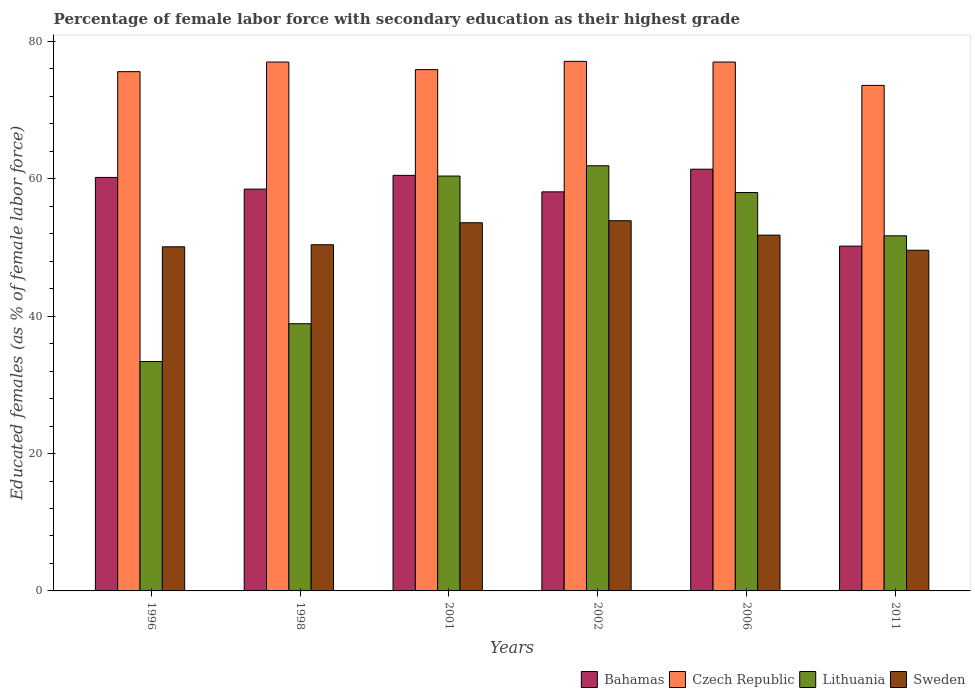How many different coloured bars are there?
Give a very brief answer. 4. How many groups of bars are there?
Keep it short and to the point. 6. Are the number of bars per tick equal to the number of legend labels?
Offer a very short reply. Yes. How many bars are there on the 3rd tick from the right?
Your response must be concise. 4. What is the percentage of female labor force with secondary education in Sweden in 1996?
Give a very brief answer. 50.1. Across all years, what is the maximum percentage of female labor force with secondary education in Sweden?
Offer a very short reply. 53.9. Across all years, what is the minimum percentage of female labor force with secondary education in Lithuania?
Keep it short and to the point. 33.4. In which year was the percentage of female labor force with secondary education in Lithuania maximum?
Keep it short and to the point. 2002. What is the total percentage of female labor force with secondary education in Bahamas in the graph?
Ensure brevity in your answer.  348.9. What is the difference between the percentage of female labor force with secondary education in Lithuania in 1998 and that in 2001?
Offer a very short reply. -21.5. What is the difference between the percentage of female labor force with secondary education in Lithuania in 2001 and the percentage of female labor force with secondary education in Sweden in 1996?
Ensure brevity in your answer.  10.3. What is the average percentage of female labor force with secondary education in Czech Republic per year?
Your answer should be compact. 76.03. In the year 2011, what is the difference between the percentage of female labor force with secondary education in Sweden and percentage of female labor force with secondary education in Bahamas?
Keep it short and to the point. -0.6. What is the ratio of the percentage of female labor force with secondary education in Sweden in 1996 to that in 2001?
Your response must be concise. 0.93. Is the percentage of female labor force with secondary education in Czech Republic in 2001 less than that in 2006?
Keep it short and to the point. Yes. What is the difference between the highest and the second highest percentage of female labor force with secondary education in Czech Republic?
Make the answer very short. 0.1. What is the difference between the highest and the lowest percentage of female labor force with secondary education in Czech Republic?
Your answer should be compact. 3.5. In how many years, is the percentage of female labor force with secondary education in Sweden greater than the average percentage of female labor force with secondary education in Sweden taken over all years?
Offer a terse response. 3. Is it the case that in every year, the sum of the percentage of female labor force with secondary education in Lithuania and percentage of female labor force with secondary education in Czech Republic is greater than the sum of percentage of female labor force with secondary education in Bahamas and percentage of female labor force with secondary education in Sweden?
Your answer should be compact. No. What does the 2nd bar from the left in 2011 represents?
Your answer should be compact. Czech Republic. What does the 2nd bar from the right in 2001 represents?
Provide a succinct answer. Lithuania. Is it the case that in every year, the sum of the percentage of female labor force with secondary education in Bahamas and percentage of female labor force with secondary education in Lithuania is greater than the percentage of female labor force with secondary education in Czech Republic?
Provide a succinct answer. Yes. What is the difference between two consecutive major ticks on the Y-axis?
Make the answer very short. 20. Where does the legend appear in the graph?
Your answer should be very brief. Bottom right. How many legend labels are there?
Make the answer very short. 4. What is the title of the graph?
Ensure brevity in your answer.  Percentage of female labor force with secondary education as their highest grade. Does "Europe(developing only)" appear as one of the legend labels in the graph?
Your response must be concise. No. What is the label or title of the X-axis?
Your response must be concise. Years. What is the label or title of the Y-axis?
Your answer should be very brief. Educated females (as % of female labor force). What is the Educated females (as % of female labor force) of Bahamas in 1996?
Your answer should be very brief. 60.2. What is the Educated females (as % of female labor force) in Czech Republic in 1996?
Offer a very short reply. 75.6. What is the Educated females (as % of female labor force) of Lithuania in 1996?
Your answer should be compact. 33.4. What is the Educated females (as % of female labor force) of Sweden in 1996?
Provide a short and direct response. 50.1. What is the Educated females (as % of female labor force) of Bahamas in 1998?
Ensure brevity in your answer.  58.5. What is the Educated females (as % of female labor force) of Czech Republic in 1998?
Offer a very short reply. 77. What is the Educated females (as % of female labor force) of Lithuania in 1998?
Give a very brief answer. 38.9. What is the Educated females (as % of female labor force) in Sweden in 1998?
Ensure brevity in your answer.  50.4. What is the Educated females (as % of female labor force) of Bahamas in 2001?
Provide a short and direct response. 60.5. What is the Educated females (as % of female labor force) of Czech Republic in 2001?
Give a very brief answer. 75.9. What is the Educated females (as % of female labor force) of Lithuania in 2001?
Keep it short and to the point. 60.4. What is the Educated females (as % of female labor force) of Sweden in 2001?
Offer a terse response. 53.6. What is the Educated females (as % of female labor force) of Bahamas in 2002?
Your answer should be compact. 58.1. What is the Educated females (as % of female labor force) in Czech Republic in 2002?
Keep it short and to the point. 77.1. What is the Educated females (as % of female labor force) of Lithuania in 2002?
Provide a short and direct response. 61.9. What is the Educated females (as % of female labor force) in Sweden in 2002?
Your answer should be very brief. 53.9. What is the Educated females (as % of female labor force) in Bahamas in 2006?
Your answer should be compact. 61.4. What is the Educated females (as % of female labor force) in Sweden in 2006?
Your answer should be very brief. 51.8. What is the Educated females (as % of female labor force) in Bahamas in 2011?
Provide a short and direct response. 50.2. What is the Educated females (as % of female labor force) in Czech Republic in 2011?
Provide a short and direct response. 73.6. What is the Educated females (as % of female labor force) in Lithuania in 2011?
Your answer should be compact. 51.7. What is the Educated females (as % of female labor force) of Sweden in 2011?
Offer a very short reply. 49.6. Across all years, what is the maximum Educated females (as % of female labor force) in Bahamas?
Provide a succinct answer. 61.4. Across all years, what is the maximum Educated females (as % of female labor force) of Czech Republic?
Ensure brevity in your answer.  77.1. Across all years, what is the maximum Educated females (as % of female labor force) in Lithuania?
Keep it short and to the point. 61.9. Across all years, what is the maximum Educated females (as % of female labor force) of Sweden?
Provide a short and direct response. 53.9. Across all years, what is the minimum Educated females (as % of female labor force) of Bahamas?
Offer a very short reply. 50.2. Across all years, what is the minimum Educated females (as % of female labor force) in Czech Republic?
Your answer should be compact. 73.6. Across all years, what is the minimum Educated females (as % of female labor force) of Lithuania?
Make the answer very short. 33.4. Across all years, what is the minimum Educated females (as % of female labor force) of Sweden?
Provide a succinct answer. 49.6. What is the total Educated females (as % of female labor force) in Bahamas in the graph?
Offer a terse response. 348.9. What is the total Educated females (as % of female labor force) of Czech Republic in the graph?
Offer a terse response. 456.2. What is the total Educated females (as % of female labor force) in Lithuania in the graph?
Your response must be concise. 304.3. What is the total Educated females (as % of female labor force) of Sweden in the graph?
Keep it short and to the point. 309.4. What is the difference between the Educated females (as % of female labor force) in Bahamas in 1996 and that in 1998?
Offer a very short reply. 1.7. What is the difference between the Educated females (as % of female labor force) in Sweden in 1996 and that in 1998?
Make the answer very short. -0.3. What is the difference between the Educated females (as % of female labor force) in Bahamas in 1996 and that in 2001?
Your answer should be compact. -0.3. What is the difference between the Educated females (as % of female labor force) of Czech Republic in 1996 and that in 2001?
Your answer should be compact. -0.3. What is the difference between the Educated females (as % of female labor force) in Sweden in 1996 and that in 2001?
Your response must be concise. -3.5. What is the difference between the Educated females (as % of female labor force) in Bahamas in 1996 and that in 2002?
Your response must be concise. 2.1. What is the difference between the Educated females (as % of female labor force) of Czech Republic in 1996 and that in 2002?
Your answer should be very brief. -1.5. What is the difference between the Educated females (as % of female labor force) of Lithuania in 1996 and that in 2002?
Keep it short and to the point. -28.5. What is the difference between the Educated females (as % of female labor force) in Bahamas in 1996 and that in 2006?
Your answer should be compact. -1.2. What is the difference between the Educated females (as % of female labor force) in Czech Republic in 1996 and that in 2006?
Keep it short and to the point. -1.4. What is the difference between the Educated females (as % of female labor force) of Lithuania in 1996 and that in 2006?
Give a very brief answer. -24.6. What is the difference between the Educated females (as % of female labor force) of Sweden in 1996 and that in 2006?
Provide a short and direct response. -1.7. What is the difference between the Educated females (as % of female labor force) in Czech Republic in 1996 and that in 2011?
Offer a terse response. 2. What is the difference between the Educated females (as % of female labor force) of Lithuania in 1996 and that in 2011?
Provide a short and direct response. -18.3. What is the difference between the Educated females (as % of female labor force) in Lithuania in 1998 and that in 2001?
Provide a short and direct response. -21.5. What is the difference between the Educated females (as % of female labor force) in Bahamas in 1998 and that in 2002?
Give a very brief answer. 0.4. What is the difference between the Educated females (as % of female labor force) in Bahamas in 1998 and that in 2006?
Your answer should be compact. -2.9. What is the difference between the Educated females (as % of female labor force) of Lithuania in 1998 and that in 2006?
Keep it short and to the point. -19.1. What is the difference between the Educated females (as % of female labor force) of Sweden in 1998 and that in 2006?
Your response must be concise. -1.4. What is the difference between the Educated females (as % of female labor force) in Bahamas in 1998 and that in 2011?
Your answer should be very brief. 8.3. What is the difference between the Educated females (as % of female labor force) of Czech Republic in 1998 and that in 2011?
Keep it short and to the point. 3.4. What is the difference between the Educated females (as % of female labor force) in Sweden in 1998 and that in 2011?
Offer a terse response. 0.8. What is the difference between the Educated females (as % of female labor force) in Bahamas in 2001 and that in 2002?
Ensure brevity in your answer.  2.4. What is the difference between the Educated females (as % of female labor force) of Sweden in 2001 and that in 2002?
Your answer should be compact. -0.3. What is the difference between the Educated females (as % of female labor force) of Lithuania in 2001 and that in 2006?
Your answer should be very brief. 2.4. What is the difference between the Educated females (as % of female labor force) in Sweden in 2001 and that in 2006?
Offer a very short reply. 1.8. What is the difference between the Educated females (as % of female labor force) of Bahamas in 2001 and that in 2011?
Give a very brief answer. 10.3. What is the difference between the Educated females (as % of female labor force) of Sweden in 2001 and that in 2011?
Keep it short and to the point. 4. What is the difference between the Educated females (as % of female labor force) in Czech Republic in 2002 and that in 2006?
Keep it short and to the point. 0.1. What is the difference between the Educated females (as % of female labor force) of Sweden in 2002 and that in 2006?
Ensure brevity in your answer.  2.1. What is the difference between the Educated females (as % of female labor force) of Sweden in 2002 and that in 2011?
Offer a very short reply. 4.3. What is the difference between the Educated females (as % of female labor force) in Bahamas in 2006 and that in 2011?
Keep it short and to the point. 11.2. What is the difference between the Educated females (as % of female labor force) of Lithuania in 2006 and that in 2011?
Keep it short and to the point. 6.3. What is the difference between the Educated females (as % of female labor force) in Sweden in 2006 and that in 2011?
Offer a very short reply. 2.2. What is the difference between the Educated females (as % of female labor force) in Bahamas in 1996 and the Educated females (as % of female labor force) in Czech Republic in 1998?
Your answer should be compact. -16.8. What is the difference between the Educated females (as % of female labor force) of Bahamas in 1996 and the Educated females (as % of female labor force) of Lithuania in 1998?
Your answer should be compact. 21.3. What is the difference between the Educated females (as % of female labor force) in Czech Republic in 1996 and the Educated females (as % of female labor force) in Lithuania in 1998?
Your answer should be compact. 36.7. What is the difference between the Educated females (as % of female labor force) in Czech Republic in 1996 and the Educated females (as % of female labor force) in Sweden in 1998?
Offer a terse response. 25.2. What is the difference between the Educated females (as % of female labor force) of Bahamas in 1996 and the Educated females (as % of female labor force) of Czech Republic in 2001?
Your answer should be very brief. -15.7. What is the difference between the Educated females (as % of female labor force) in Czech Republic in 1996 and the Educated females (as % of female labor force) in Lithuania in 2001?
Offer a terse response. 15.2. What is the difference between the Educated females (as % of female labor force) in Czech Republic in 1996 and the Educated females (as % of female labor force) in Sweden in 2001?
Give a very brief answer. 22. What is the difference between the Educated females (as % of female labor force) in Lithuania in 1996 and the Educated females (as % of female labor force) in Sweden in 2001?
Ensure brevity in your answer.  -20.2. What is the difference between the Educated females (as % of female labor force) of Bahamas in 1996 and the Educated females (as % of female labor force) of Czech Republic in 2002?
Make the answer very short. -16.9. What is the difference between the Educated females (as % of female labor force) of Bahamas in 1996 and the Educated females (as % of female labor force) of Lithuania in 2002?
Offer a very short reply. -1.7. What is the difference between the Educated females (as % of female labor force) of Czech Republic in 1996 and the Educated females (as % of female labor force) of Sweden in 2002?
Your answer should be very brief. 21.7. What is the difference between the Educated females (as % of female labor force) of Lithuania in 1996 and the Educated females (as % of female labor force) of Sweden in 2002?
Keep it short and to the point. -20.5. What is the difference between the Educated females (as % of female labor force) of Bahamas in 1996 and the Educated females (as % of female labor force) of Czech Republic in 2006?
Keep it short and to the point. -16.8. What is the difference between the Educated females (as % of female labor force) of Bahamas in 1996 and the Educated females (as % of female labor force) of Sweden in 2006?
Give a very brief answer. 8.4. What is the difference between the Educated females (as % of female labor force) in Czech Republic in 1996 and the Educated females (as % of female labor force) in Lithuania in 2006?
Provide a short and direct response. 17.6. What is the difference between the Educated females (as % of female labor force) in Czech Republic in 1996 and the Educated females (as % of female labor force) in Sweden in 2006?
Keep it short and to the point. 23.8. What is the difference between the Educated females (as % of female labor force) of Lithuania in 1996 and the Educated females (as % of female labor force) of Sweden in 2006?
Your response must be concise. -18.4. What is the difference between the Educated females (as % of female labor force) in Bahamas in 1996 and the Educated females (as % of female labor force) in Sweden in 2011?
Your response must be concise. 10.6. What is the difference between the Educated females (as % of female labor force) of Czech Republic in 1996 and the Educated females (as % of female labor force) of Lithuania in 2011?
Your answer should be compact. 23.9. What is the difference between the Educated females (as % of female labor force) in Lithuania in 1996 and the Educated females (as % of female labor force) in Sweden in 2011?
Ensure brevity in your answer.  -16.2. What is the difference between the Educated females (as % of female labor force) in Bahamas in 1998 and the Educated females (as % of female labor force) in Czech Republic in 2001?
Give a very brief answer. -17.4. What is the difference between the Educated females (as % of female labor force) of Bahamas in 1998 and the Educated females (as % of female labor force) of Sweden in 2001?
Keep it short and to the point. 4.9. What is the difference between the Educated females (as % of female labor force) of Czech Republic in 1998 and the Educated females (as % of female labor force) of Sweden in 2001?
Offer a very short reply. 23.4. What is the difference between the Educated females (as % of female labor force) of Lithuania in 1998 and the Educated females (as % of female labor force) of Sweden in 2001?
Give a very brief answer. -14.7. What is the difference between the Educated females (as % of female labor force) in Bahamas in 1998 and the Educated females (as % of female labor force) in Czech Republic in 2002?
Ensure brevity in your answer.  -18.6. What is the difference between the Educated females (as % of female labor force) in Bahamas in 1998 and the Educated females (as % of female labor force) in Lithuania in 2002?
Offer a terse response. -3.4. What is the difference between the Educated females (as % of female labor force) of Bahamas in 1998 and the Educated females (as % of female labor force) of Sweden in 2002?
Your answer should be compact. 4.6. What is the difference between the Educated females (as % of female labor force) in Czech Republic in 1998 and the Educated females (as % of female labor force) in Lithuania in 2002?
Your answer should be compact. 15.1. What is the difference between the Educated females (as % of female labor force) in Czech Republic in 1998 and the Educated females (as % of female labor force) in Sweden in 2002?
Give a very brief answer. 23.1. What is the difference between the Educated females (as % of female labor force) of Bahamas in 1998 and the Educated females (as % of female labor force) of Czech Republic in 2006?
Keep it short and to the point. -18.5. What is the difference between the Educated females (as % of female labor force) of Bahamas in 1998 and the Educated females (as % of female labor force) of Sweden in 2006?
Provide a short and direct response. 6.7. What is the difference between the Educated females (as % of female labor force) of Czech Republic in 1998 and the Educated females (as % of female labor force) of Lithuania in 2006?
Keep it short and to the point. 19. What is the difference between the Educated females (as % of female labor force) of Czech Republic in 1998 and the Educated females (as % of female labor force) of Sweden in 2006?
Offer a terse response. 25.2. What is the difference between the Educated females (as % of female labor force) in Lithuania in 1998 and the Educated females (as % of female labor force) in Sweden in 2006?
Offer a terse response. -12.9. What is the difference between the Educated females (as % of female labor force) of Bahamas in 1998 and the Educated females (as % of female labor force) of Czech Republic in 2011?
Your answer should be very brief. -15.1. What is the difference between the Educated females (as % of female labor force) of Bahamas in 1998 and the Educated females (as % of female labor force) of Lithuania in 2011?
Keep it short and to the point. 6.8. What is the difference between the Educated females (as % of female labor force) of Czech Republic in 1998 and the Educated females (as % of female labor force) of Lithuania in 2011?
Keep it short and to the point. 25.3. What is the difference between the Educated females (as % of female labor force) of Czech Republic in 1998 and the Educated females (as % of female labor force) of Sweden in 2011?
Offer a very short reply. 27.4. What is the difference between the Educated females (as % of female labor force) of Bahamas in 2001 and the Educated females (as % of female labor force) of Czech Republic in 2002?
Provide a succinct answer. -16.6. What is the difference between the Educated females (as % of female labor force) of Czech Republic in 2001 and the Educated females (as % of female labor force) of Lithuania in 2002?
Your answer should be compact. 14. What is the difference between the Educated females (as % of female labor force) of Bahamas in 2001 and the Educated females (as % of female labor force) of Czech Republic in 2006?
Your response must be concise. -16.5. What is the difference between the Educated females (as % of female labor force) of Bahamas in 2001 and the Educated females (as % of female labor force) of Lithuania in 2006?
Ensure brevity in your answer.  2.5. What is the difference between the Educated females (as % of female labor force) in Bahamas in 2001 and the Educated females (as % of female labor force) in Sweden in 2006?
Offer a very short reply. 8.7. What is the difference between the Educated females (as % of female labor force) in Czech Republic in 2001 and the Educated females (as % of female labor force) in Sweden in 2006?
Make the answer very short. 24.1. What is the difference between the Educated females (as % of female labor force) of Bahamas in 2001 and the Educated females (as % of female labor force) of Lithuania in 2011?
Make the answer very short. 8.8. What is the difference between the Educated females (as % of female labor force) in Bahamas in 2001 and the Educated females (as % of female labor force) in Sweden in 2011?
Give a very brief answer. 10.9. What is the difference between the Educated females (as % of female labor force) of Czech Republic in 2001 and the Educated females (as % of female labor force) of Lithuania in 2011?
Offer a very short reply. 24.2. What is the difference between the Educated females (as % of female labor force) in Czech Republic in 2001 and the Educated females (as % of female labor force) in Sweden in 2011?
Make the answer very short. 26.3. What is the difference between the Educated females (as % of female labor force) in Bahamas in 2002 and the Educated females (as % of female labor force) in Czech Republic in 2006?
Your answer should be very brief. -18.9. What is the difference between the Educated females (as % of female labor force) of Czech Republic in 2002 and the Educated females (as % of female labor force) of Sweden in 2006?
Provide a short and direct response. 25.3. What is the difference between the Educated females (as % of female labor force) in Lithuania in 2002 and the Educated females (as % of female labor force) in Sweden in 2006?
Provide a succinct answer. 10.1. What is the difference between the Educated females (as % of female labor force) in Bahamas in 2002 and the Educated females (as % of female labor force) in Czech Republic in 2011?
Make the answer very short. -15.5. What is the difference between the Educated females (as % of female labor force) in Bahamas in 2002 and the Educated females (as % of female labor force) in Lithuania in 2011?
Give a very brief answer. 6.4. What is the difference between the Educated females (as % of female labor force) in Bahamas in 2002 and the Educated females (as % of female labor force) in Sweden in 2011?
Your answer should be very brief. 8.5. What is the difference between the Educated females (as % of female labor force) of Czech Republic in 2002 and the Educated females (as % of female labor force) of Lithuania in 2011?
Offer a very short reply. 25.4. What is the difference between the Educated females (as % of female labor force) of Czech Republic in 2002 and the Educated females (as % of female labor force) of Sweden in 2011?
Offer a very short reply. 27.5. What is the difference between the Educated females (as % of female labor force) in Lithuania in 2002 and the Educated females (as % of female labor force) in Sweden in 2011?
Your response must be concise. 12.3. What is the difference between the Educated females (as % of female labor force) of Bahamas in 2006 and the Educated females (as % of female labor force) of Sweden in 2011?
Give a very brief answer. 11.8. What is the difference between the Educated females (as % of female labor force) in Czech Republic in 2006 and the Educated females (as % of female labor force) in Lithuania in 2011?
Keep it short and to the point. 25.3. What is the difference between the Educated females (as % of female labor force) of Czech Republic in 2006 and the Educated females (as % of female labor force) of Sweden in 2011?
Provide a short and direct response. 27.4. What is the difference between the Educated females (as % of female labor force) in Lithuania in 2006 and the Educated females (as % of female labor force) in Sweden in 2011?
Provide a short and direct response. 8.4. What is the average Educated females (as % of female labor force) in Bahamas per year?
Offer a very short reply. 58.15. What is the average Educated females (as % of female labor force) in Czech Republic per year?
Provide a short and direct response. 76.03. What is the average Educated females (as % of female labor force) in Lithuania per year?
Provide a succinct answer. 50.72. What is the average Educated females (as % of female labor force) of Sweden per year?
Offer a terse response. 51.57. In the year 1996, what is the difference between the Educated females (as % of female labor force) in Bahamas and Educated females (as % of female labor force) in Czech Republic?
Your answer should be compact. -15.4. In the year 1996, what is the difference between the Educated females (as % of female labor force) in Bahamas and Educated females (as % of female labor force) in Lithuania?
Give a very brief answer. 26.8. In the year 1996, what is the difference between the Educated females (as % of female labor force) of Bahamas and Educated females (as % of female labor force) of Sweden?
Provide a short and direct response. 10.1. In the year 1996, what is the difference between the Educated females (as % of female labor force) of Czech Republic and Educated females (as % of female labor force) of Lithuania?
Offer a terse response. 42.2. In the year 1996, what is the difference between the Educated females (as % of female labor force) of Lithuania and Educated females (as % of female labor force) of Sweden?
Your response must be concise. -16.7. In the year 1998, what is the difference between the Educated females (as % of female labor force) of Bahamas and Educated females (as % of female labor force) of Czech Republic?
Ensure brevity in your answer.  -18.5. In the year 1998, what is the difference between the Educated females (as % of female labor force) in Bahamas and Educated females (as % of female labor force) in Lithuania?
Ensure brevity in your answer.  19.6. In the year 1998, what is the difference between the Educated females (as % of female labor force) of Bahamas and Educated females (as % of female labor force) of Sweden?
Your answer should be compact. 8.1. In the year 1998, what is the difference between the Educated females (as % of female labor force) in Czech Republic and Educated females (as % of female labor force) in Lithuania?
Keep it short and to the point. 38.1. In the year 1998, what is the difference between the Educated females (as % of female labor force) in Czech Republic and Educated females (as % of female labor force) in Sweden?
Make the answer very short. 26.6. In the year 2001, what is the difference between the Educated females (as % of female labor force) in Bahamas and Educated females (as % of female labor force) in Czech Republic?
Make the answer very short. -15.4. In the year 2001, what is the difference between the Educated females (as % of female labor force) in Bahamas and Educated females (as % of female labor force) in Lithuania?
Your answer should be compact. 0.1. In the year 2001, what is the difference between the Educated females (as % of female labor force) of Czech Republic and Educated females (as % of female labor force) of Sweden?
Offer a terse response. 22.3. In the year 2001, what is the difference between the Educated females (as % of female labor force) of Lithuania and Educated females (as % of female labor force) of Sweden?
Offer a very short reply. 6.8. In the year 2002, what is the difference between the Educated females (as % of female labor force) in Bahamas and Educated females (as % of female labor force) in Sweden?
Your response must be concise. 4.2. In the year 2002, what is the difference between the Educated females (as % of female labor force) of Czech Republic and Educated females (as % of female labor force) of Sweden?
Keep it short and to the point. 23.2. In the year 2006, what is the difference between the Educated females (as % of female labor force) in Bahamas and Educated females (as % of female labor force) in Czech Republic?
Give a very brief answer. -15.6. In the year 2006, what is the difference between the Educated females (as % of female labor force) of Czech Republic and Educated females (as % of female labor force) of Lithuania?
Your answer should be very brief. 19. In the year 2006, what is the difference between the Educated females (as % of female labor force) of Czech Republic and Educated females (as % of female labor force) of Sweden?
Give a very brief answer. 25.2. In the year 2011, what is the difference between the Educated females (as % of female labor force) in Bahamas and Educated females (as % of female labor force) in Czech Republic?
Give a very brief answer. -23.4. In the year 2011, what is the difference between the Educated females (as % of female labor force) in Bahamas and Educated females (as % of female labor force) in Lithuania?
Offer a terse response. -1.5. In the year 2011, what is the difference between the Educated females (as % of female labor force) in Czech Republic and Educated females (as % of female labor force) in Lithuania?
Make the answer very short. 21.9. In the year 2011, what is the difference between the Educated females (as % of female labor force) in Czech Republic and Educated females (as % of female labor force) in Sweden?
Keep it short and to the point. 24. In the year 2011, what is the difference between the Educated females (as % of female labor force) of Lithuania and Educated females (as % of female labor force) of Sweden?
Your answer should be compact. 2.1. What is the ratio of the Educated females (as % of female labor force) in Bahamas in 1996 to that in 1998?
Ensure brevity in your answer.  1.03. What is the ratio of the Educated females (as % of female labor force) of Czech Republic in 1996 to that in 1998?
Offer a terse response. 0.98. What is the ratio of the Educated females (as % of female labor force) in Lithuania in 1996 to that in 1998?
Offer a terse response. 0.86. What is the ratio of the Educated females (as % of female labor force) of Sweden in 1996 to that in 1998?
Your answer should be compact. 0.99. What is the ratio of the Educated females (as % of female labor force) of Bahamas in 1996 to that in 2001?
Provide a short and direct response. 0.99. What is the ratio of the Educated females (as % of female labor force) in Czech Republic in 1996 to that in 2001?
Your response must be concise. 1. What is the ratio of the Educated females (as % of female labor force) of Lithuania in 1996 to that in 2001?
Make the answer very short. 0.55. What is the ratio of the Educated females (as % of female labor force) of Sweden in 1996 to that in 2001?
Provide a succinct answer. 0.93. What is the ratio of the Educated females (as % of female labor force) in Bahamas in 1996 to that in 2002?
Offer a very short reply. 1.04. What is the ratio of the Educated females (as % of female labor force) of Czech Republic in 1996 to that in 2002?
Your answer should be very brief. 0.98. What is the ratio of the Educated females (as % of female labor force) of Lithuania in 1996 to that in 2002?
Your response must be concise. 0.54. What is the ratio of the Educated females (as % of female labor force) in Sweden in 1996 to that in 2002?
Give a very brief answer. 0.93. What is the ratio of the Educated females (as % of female labor force) in Bahamas in 1996 to that in 2006?
Provide a short and direct response. 0.98. What is the ratio of the Educated females (as % of female labor force) of Czech Republic in 1996 to that in 2006?
Offer a very short reply. 0.98. What is the ratio of the Educated females (as % of female labor force) in Lithuania in 1996 to that in 2006?
Your response must be concise. 0.58. What is the ratio of the Educated females (as % of female labor force) in Sweden in 1996 to that in 2006?
Offer a very short reply. 0.97. What is the ratio of the Educated females (as % of female labor force) of Bahamas in 1996 to that in 2011?
Your answer should be very brief. 1.2. What is the ratio of the Educated females (as % of female labor force) in Czech Republic in 1996 to that in 2011?
Make the answer very short. 1.03. What is the ratio of the Educated females (as % of female labor force) in Lithuania in 1996 to that in 2011?
Your response must be concise. 0.65. What is the ratio of the Educated females (as % of female labor force) of Bahamas in 1998 to that in 2001?
Ensure brevity in your answer.  0.97. What is the ratio of the Educated females (as % of female labor force) of Czech Republic in 1998 to that in 2001?
Provide a short and direct response. 1.01. What is the ratio of the Educated females (as % of female labor force) of Lithuania in 1998 to that in 2001?
Provide a succinct answer. 0.64. What is the ratio of the Educated females (as % of female labor force) in Sweden in 1998 to that in 2001?
Make the answer very short. 0.94. What is the ratio of the Educated females (as % of female labor force) in Lithuania in 1998 to that in 2002?
Give a very brief answer. 0.63. What is the ratio of the Educated females (as % of female labor force) in Sweden in 1998 to that in 2002?
Provide a short and direct response. 0.94. What is the ratio of the Educated females (as % of female labor force) in Bahamas in 1998 to that in 2006?
Your response must be concise. 0.95. What is the ratio of the Educated females (as % of female labor force) in Czech Republic in 1998 to that in 2006?
Keep it short and to the point. 1. What is the ratio of the Educated females (as % of female labor force) in Lithuania in 1998 to that in 2006?
Provide a short and direct response. 0.67. What is the ratio of the Educated females (as % of female labor force) in Bahamas in 1998 to that in 2011?
Your answer should be compact. 1.17. What is the ratio of the Educated females (as % of female labor force) of Czech Republic in 1998 to that in 2011?
Provide a short and direct response. 1.05. What is the ratio of the Educated females (as % of female labor force) in Lithuania in 1998 to that in 2011?
Ensure brevity in your answer.  0.75. What is the ratio of the Educated females (as % of female labor force) of Sweden in 1998 to that in 2011?
Offer a terse response. 1.02. What is the ratio of the Educated females (as % of female labor force) of Bahamas in 2001 to that in 2002?
Offer a terse response. 1.04. What is the ratio of the Educated females (as % of female labor force) in Czech Republic in 2001 to that in 2002?
Offer a very short reply. 0.98. What is the ratio of the Educated females (as % of female labor force) in Lithuania in 2001 to that in 2002?
Keep it short and to the point. 0.98. What is the ratio of the Educated females (as % of female labor force) in Sweden in 2001 to that in 2002?
Your answer should be very brief. 0.99. What is the ratio of the Educated females (as % of female labor force) in Czech Republic in 2001 to that in 2006?
Your answer should be compact. 0.99. What is the ratio of the Educated females (as % of female labor force) in Lithuania in 2001 to that in 2006?
Your answer should be compact. 1.04. What is the ratio of the Educated females (as % of female labor force) of Sweden in 2001 to that in 2006?
Offer a very short reply. 1.03. What is the ratio of the Educated females (as % of female labor force) of Bahamas in 2001 to that in 2011?
Make the answer very short. 1.21. What is the ratio of the Educated females (as % of female labor force) of Czech Republic in 2001 to that in 2011?
Provide a succinct answer. 1.03. What is the ratio of the Educated females (as % of female labor force) in Lithuania in 2001 to that in 2011?
Keep it short and to the point. 1.17. What is the ratio of the Educated females (as % of female labor force) of Sweden in 2001 to that in 2011?
Your answer should be compact. 1.08. What is the ratio of the Educated females (as % of female labor force) of Bahamas in 2002 to that in 2006?
Make the answer very short. 0.95. What is the ratio of the Educated females (as % of female labor force) of Czech Republic in 2002 to that in 2006?
Provide a short and direct response. 1. What is the ratio of the Educated females (as % of female labor force) in Lithuania in 2002 to that in 2006?
Your answer should be very brief. 1.07. What is the ratio of the Educated females (as % of female labor force) of Sweden in 2002 to that in 2006?
Provide a short and direct response. 1.04. What is the ratio of the Educated females (as % of female labor force) of Bahamas in 2002 to that in 2011?
Your answer should be compact. 1.16. What is the ratio of the Educated females (as % of female labor force) of Czech Republic in 2002 to that in 2011?
Your answer should be compact. 1.05. What is the ratio of the Educated females (as % of female labor force) in Lithuania in 2002 to that in 2011?
Provide a succinct answer. 1.2. What is the ratio of the Educated females (as % of female labor force) in Sweden in 2002 to that in 2011?
Make the answer very short. 1.09. What is the ratio of the Educated females (as % of female labor force) in Bahamas in 2006 to that in 2011?
Offer a terse response. 1.22. What is the ratio of the Educated females (as % of female labor force) of Czech Republic in 2006 to that in 2011?
Offer a terse response. 1.05. What is the ratio of the Educated females (as % of female labor force) of Lithuania in 2006 to that in 2011?
Offer a terse response. 1.12. What is the ratio of the Educated females (as % of female labor force) of Sweden in 2006 to that in 2011?
Your answer should be very brief. 1.04. What is the difference between the highest and the second highest Educated females (as % of female labor force) in Bahamas?
Your answer should be compact. 0.9. What is the difference between the highest and the second highest Educated females (as % of female labor force) of Czech Republic?
Provide a short and direct response. 0.1. What is the difference between the highest and the second highest Educated females (as % of female labor force) of Sweden?
Provide a short and direct response. 0.3. What is the difference between the highest and the lowest Educated females (as % of female labor force) of Lithuania?
Provide a succinct answer. 28.5. 